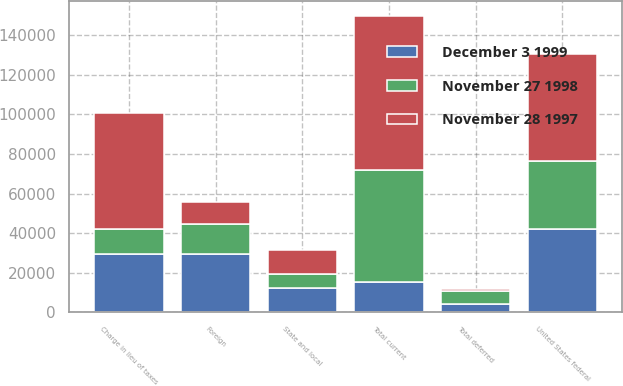Convert chart to OTSL. <chart><loc_0><loc_0><loc_500><loc_500><stacked_bar_chart><ecel><fcel>United States federal<fcel>Foreign<fcel>State and local<fcel>Total current<fcel>Total deferred<fcel>Charge in lieu of taxes<nl><fcel>November 28 1997<fcel>54097<fcel>11346<fcel>12061<fcel>77504<fcel>694<fcel>58478<nl><fcel>November 27 1998<fcel>34466<fcel>15394<fcel>6869<fcel>56729<fcel>6774<fcel>12595<nl><fcel>December 3 1999<fcel>42238<fcel>29260<fcel>12320<fcel>15394<fcel>4172<fcel>29607<nl></chart> 